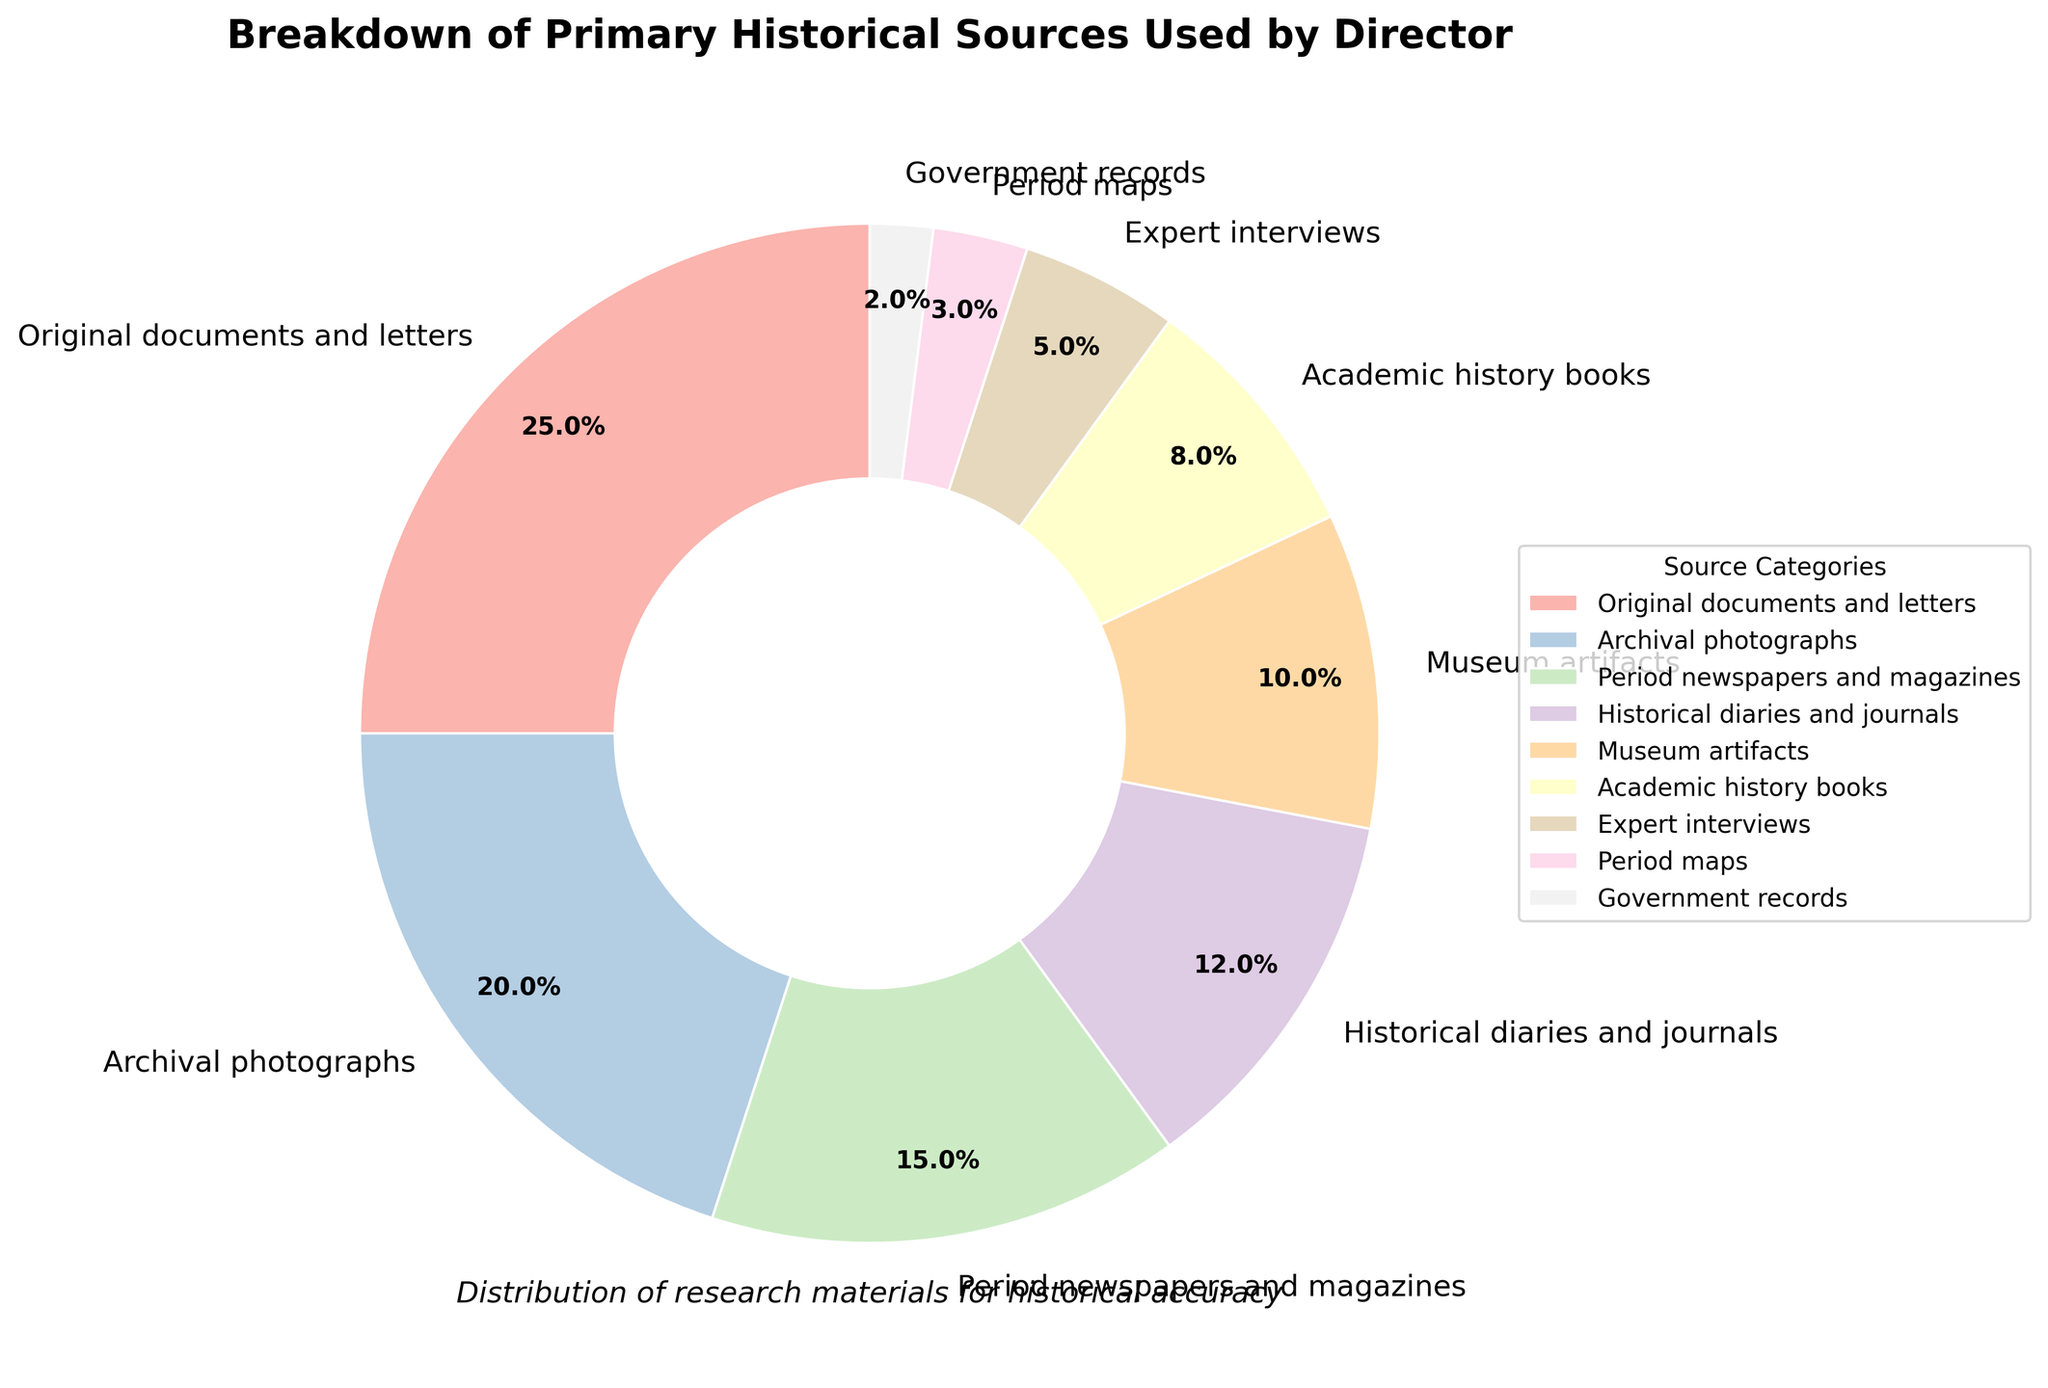What is the largest category in the pie chart? The largest category can be identified by looking at the segment that occupies the most space. In this case, "Original documents and letters" is the largest category and makes up 25% of the pie chart.
Answer: Original documents and letters Which category has a higher percentage: Archival photographs or Academic history books? To compare the two categories, look at their respective percentages. Archival photographs have 20%, while Academic history books have 8%. Since 20% is greater than 8%, Archival photographs have a higher percentage.
Answer: Archival photographs How much more significant is the use of Museum artifacts compared to Expert interviews in terms of percentage? To find the difference, subtract the percentage of Expert interviews (5%) from the percentage of Museum artifacts (10%): 10% - 5% = 5%.
Answer: 5% What is the combined percentage of Government records and Period maps? To find the combined percentage, simply add the percentages of both categories. Government records have 2%, and Period maps have 3%. Adding these together: 2% + 3% = 5%.
Answer: 5% How does the percentage of Historical diaries and journals compare to that of Period newspapers and magazines? By comparing their percentages, Historical diaries and journals make up 12%, whereas Period newspapers and magazines take up 15%. Since 15% is greater than 12%, Period newspapers and magazines have a higher percentage.
Answer: Period newspapers and magazines What is the total percentage of categories with single-digit percentages? Adding the percentages of categories with single-digit values: Academic history books (8%), Expert interviews (5%), Period maps (3%), and Government records (2%). Summing these: 8% + 5% + 3% + 2% = 18%.
Answer: 18% If the percentages of Archival photographs and Period newspapers and magazines are combined, what fraction of the pie do they represent? Adding their percentages, Archival photographs (20%) and Period newspapers and magazines (15%) give: 20% + 15% = 35%. Therefore, 35% of the pie is represented by these two categories.
Answer: 35% What is the percentage difference between the largest and smallest categories in the pie chart? The largest category is "Original documents and letters" at 25%, and the smallest category is "Government records" at 2%. The percentage difference is calculated by subtraction: 25% - 2% = 23%.
Answer: 23% Which categories have percentages less than 10% but more than 5%? To answer this, identify the categories with percentages between 5% and 10%. Only "Academic history books" falls within this range with 8%.
Answer: Academic history books What is the average percentage of all categories presented in the pie chart? First, sum all the percentages of the categories: 25 + 20 + 15 + 12 + 10 + 8 + 5 + 3 + 2 = 100%. Since there are 9 categories, the average percentage is: 100 / 9 ≈ 11.1%.
Answer: 11.1% 